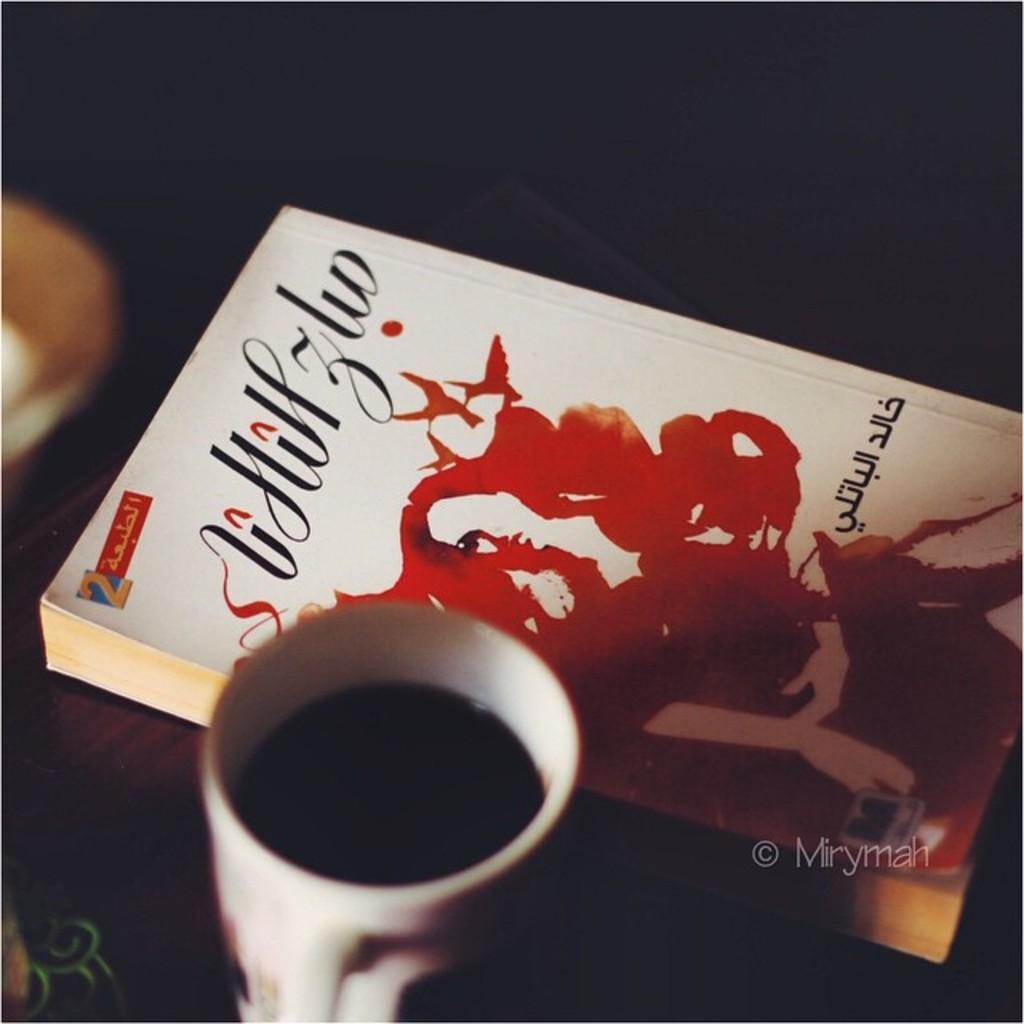Can you describe this image briefly? In the foreground of this image, there is a book and a coffee cup on a wooden surface. On the left, there is an object. At the top, there is dark. 